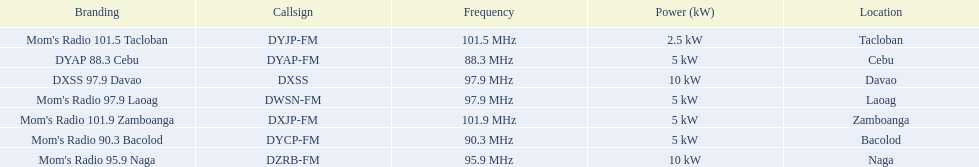What is the ultimate location displayed on this chart? Davao. 